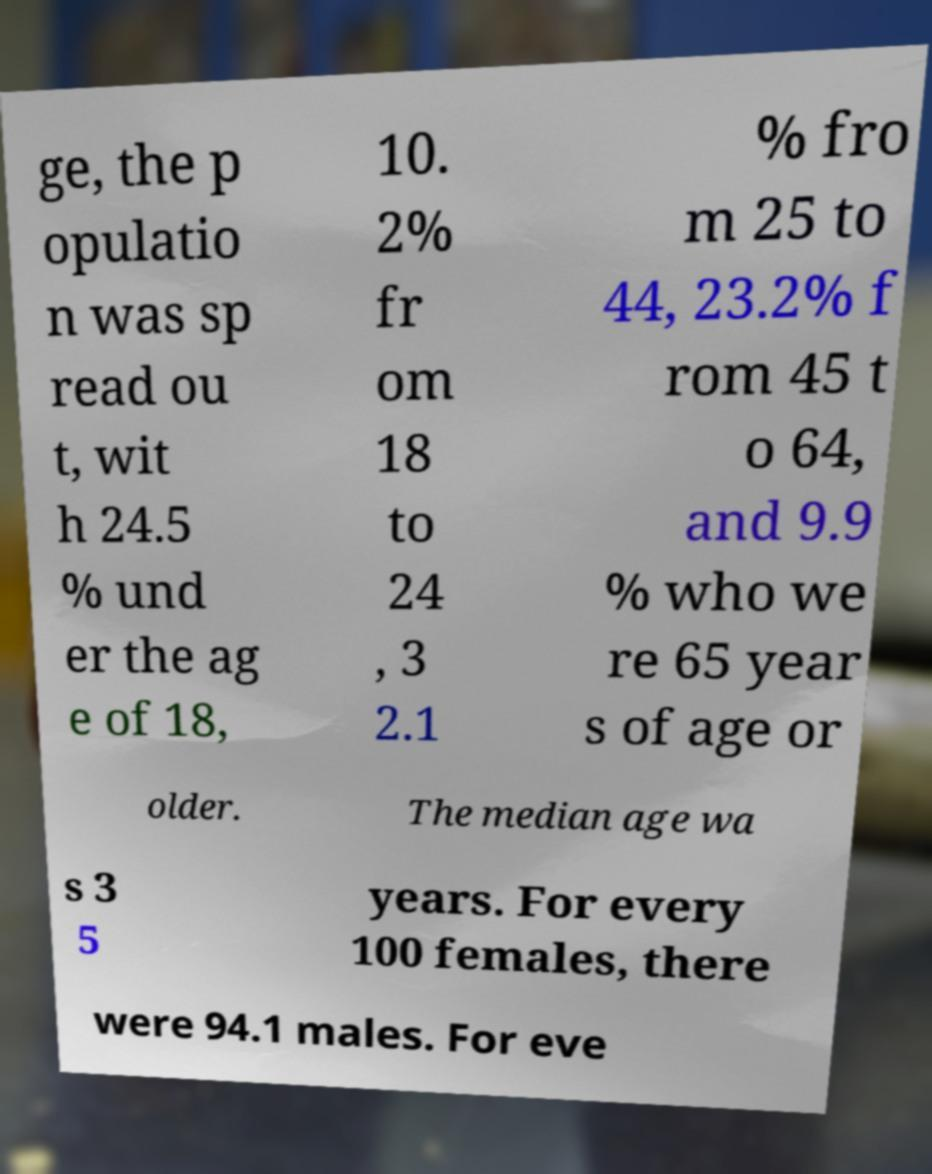Please read and relay the text visible in this image. What does it say? ge, the p opulatio n was sp read ou t, wit h 24.5 % und er the ag e of 18, 10. 2% fr om 18 to 24 , 3 2.1 % fro m 25 to 44, 23.2% f rom 45 t o 64, and 9.9 % who we re 65 year s of age or older. The median age wa s 3 5 years. For every 100 females, there were 94.1 males. For eve 